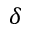<formula> <loc_0><loc_0><loc_500><loc_500>\delta</formula> 